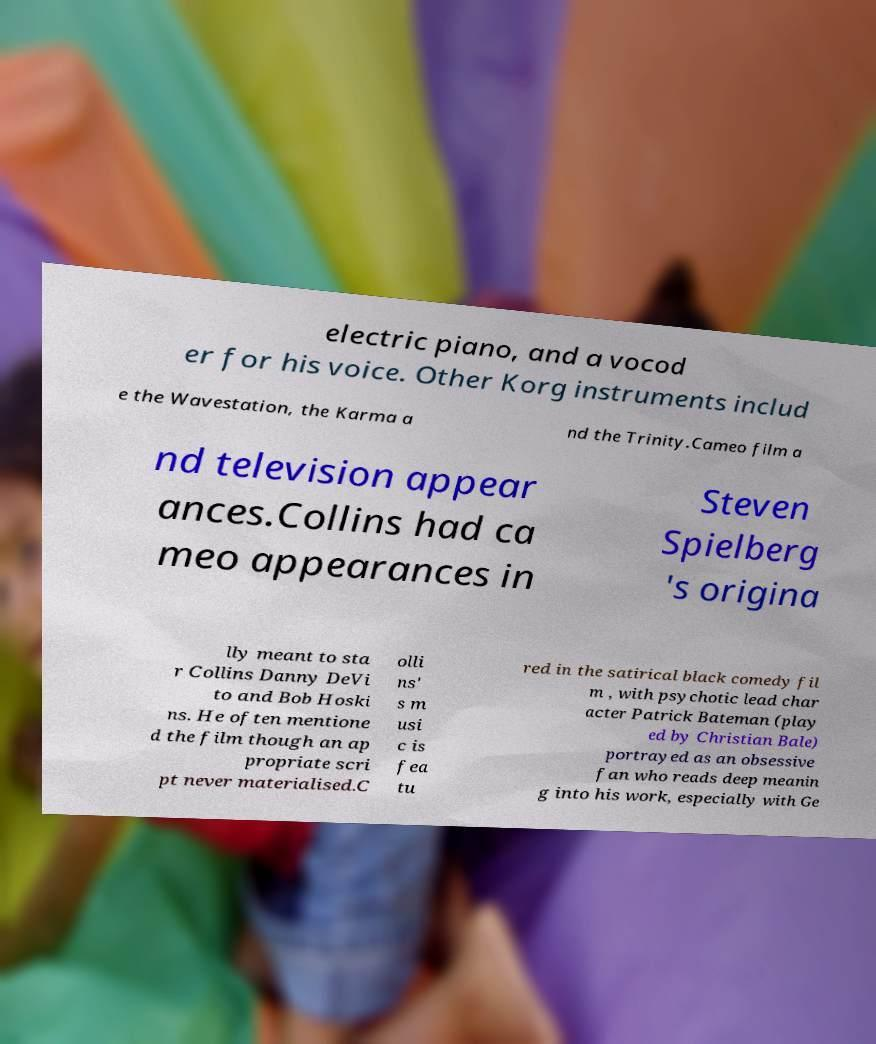There's text embedded in this image that I need extracted. Can you transcribe it verbatim? electric piano, and a vocod er for his voice. Other Korg instruments includ e the Wavestation, the Karma a nd the Trinity.Cameo film a nd television appear ances.Collins had ca meo appearances in Steven Spielberg 's origina lly meant to sta r Collins Danny DeVi to and Bob Hoski ns. He often mentione d the film though an ap propriate scri pt never materialised.C olli ns' s m usi c is fea tu red in the satirical black comedy fil m , with psychotic lead char acter Patrick Bateman (play ed by Christian Bale) portrayed as an obsessive fan who reads deep meanin g into his work, especially with Ge 